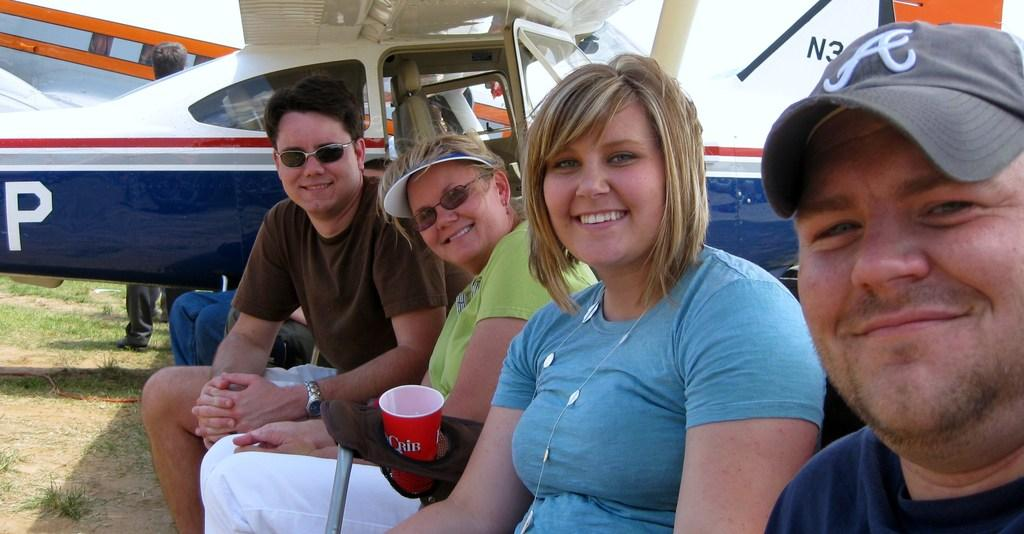What are the people in the image doing? The people in the image are sitting on chairs and smiling. What can be seen in the background of the image? There is a helicopter in the image. Is there any object placed on a chair in the image? Yes, there is a glass on a chair in the image. Can you tell me how many bees are buzzing around the helicopter in the image? There are no bees present in the image; it only features a group of people, chairs, a glass, and a helicopter. What type of berries are being served to the people in the image? There are no berries visible in the image; it only shows a bowl of ice cream and sweets. 